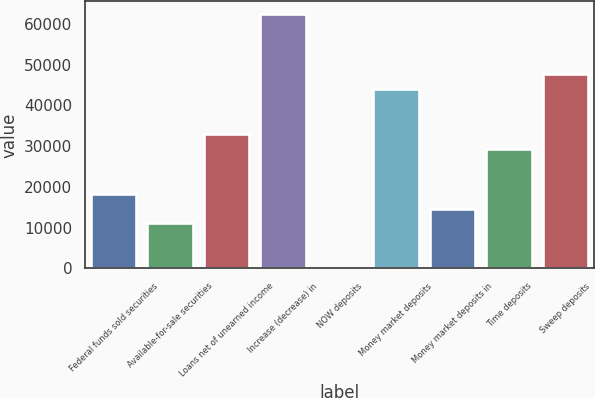<chart> <loc_0><loc_0><loc_500><loc_500><bar_chart><fcel>Federal funds sold securities<fcel>Available-for-sale securities<fcel>Loans net of unearned income<fcel>Increase (decrease) in<fcel>NOW deposits<fcel>Money market deposits<fcel>Money market deposits in<fcel>Time deposits<fcel>Sweep deposits<nl><fcel>18355<fcel>11017.4<fcel>33030.2<fcel>62380.6<fcel>11<fcel>44036.6<fcel>14686.2<fcel>29361.4<fcel>47705.4<nl></chart> 